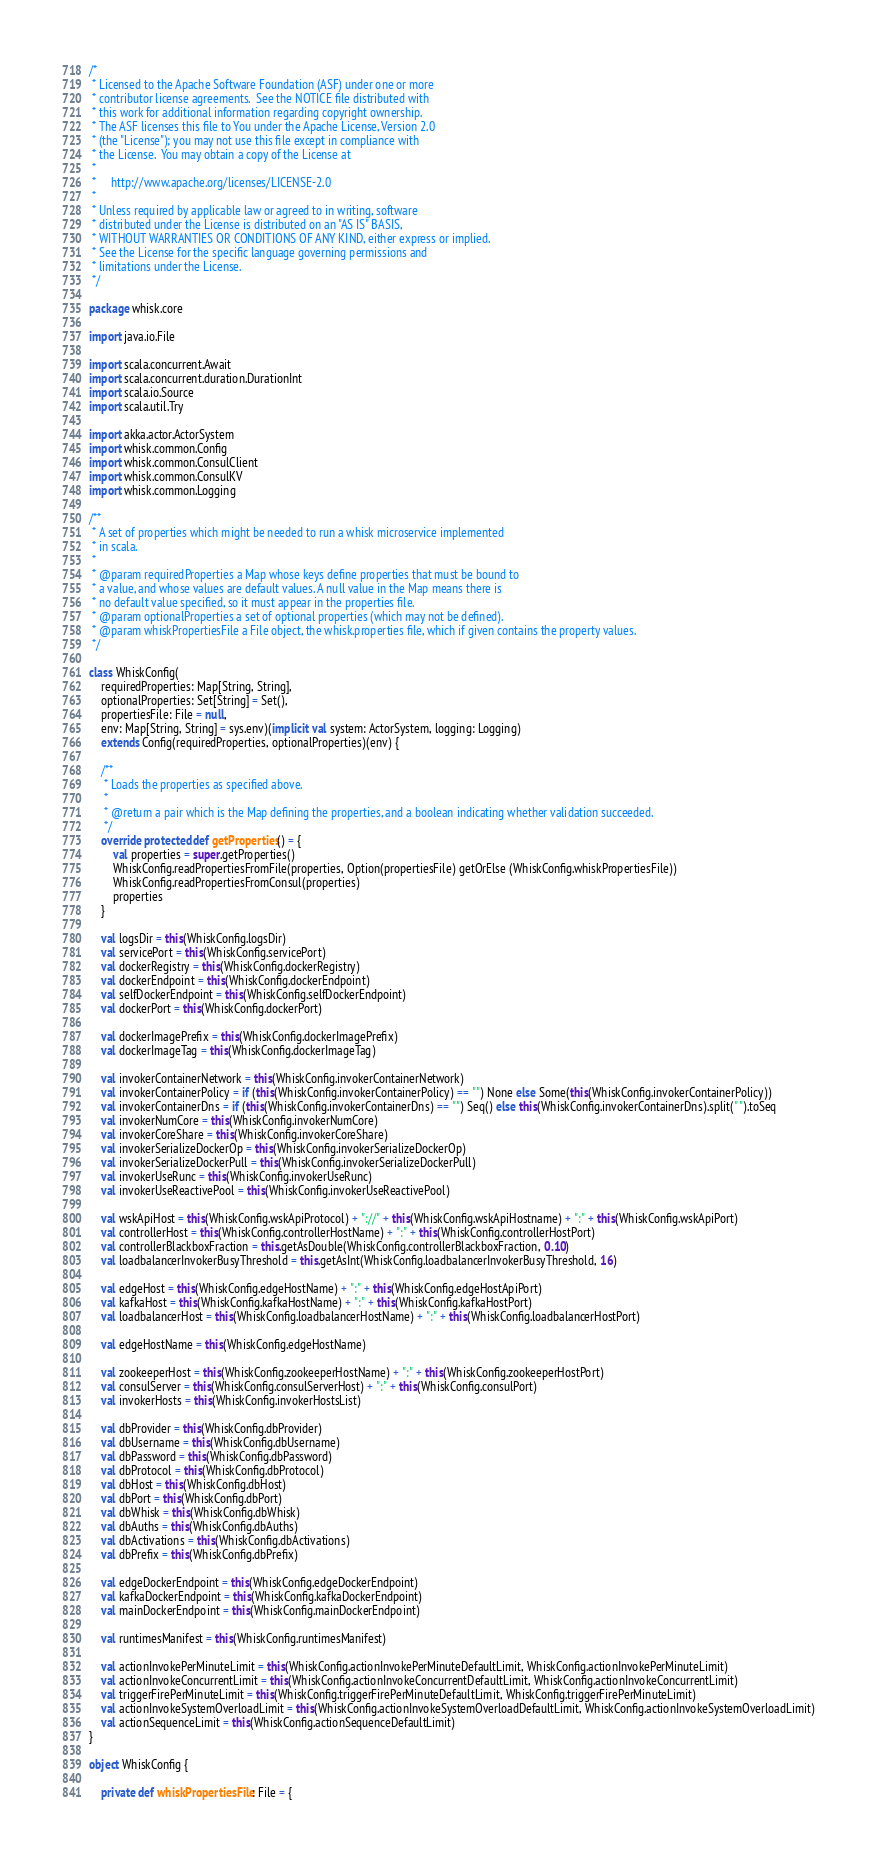<code> <loc_0><loc_0><loc_500><loc_500><_Scala_>/*
 * Licensed to the Apache Software Foundation (ASF) under one or more
 * contributor license agreements.  See the NOTICE file distributed with
 * this work for additional information regarding copyright ownership.
 * The ASF licenses this file to You under the Apache License, Version 2.0
 * (the "License"); you may not use this file except in compliance with
 * the License.  You may obtain a copy of the License at
 *
 *     http://www.apache.org/licenses/LICENSE-2.0
 *
 * Unless required by applicable law or agreed to in writing, software
 * distributed under the License is distributed on an "AS IS" BASIS,
 * WITHOUT WARRANTIES OR CONDITIONS OF ANY KIND, either express or implied.
 * See the License for the specific language governing permissions and
 * limitations under the License.
 */

package whisk.core

import java.io.File

import scala.concurrent.Await
import scala.concurrent.duration.DurationInt
import scala.io.Source
import scala.util.Try

import akka.actor.ActorSystem
import whisk.common.Config
import whisk.common.ConsulClient
import whisk.common.ConsulKV
import whisk.common.Logging

/**
 * A set of properties which might be needed to run a whisk microservice implemented
 * in scala.
 *
 * @param requiredProperties a Map whose keys define properties that must be bound to
 * a value, and whose values are default values. A null value in the Map means there is
 * no default value specified, so it must appear in the properties file.
 * @param optionalProperties a set of optional properties (which may not be defined).
 * @param whiskPropertiesFile a File object, the whisk.properties file, which if given contains the property values.
 */

class WhiskConfig(
    requiredProperties: Map[String, String],
    optionalProperties: Set[String] = Set(),
    propertiesFile: File = null,
    env: Map[String, String] = sys.env)(implicit val system: ActorSystem, logging: Logging)
    extends Config(requiredProperties, optionalProperties)(env) {

    /**
     * Loads the properties as specified above.
     *
     * @return a pair which is the Map defining the properties, and a boolean indicating whether validation succeeded.
     */
    override protected def getProperties() = {
        val properties = super.getProperties()
        WhiskConfig.readPropertiesFromFile(properties, Option(propertiesFile) getOrElse (WhiskConfig.whiskPropertiesFile))
        WhiskConfig.readPropertiesFromConsul(properties)
        properties
    }

    val logsDir = this(WhiskConfig.logsDir)
    val servicePort = this(WhiskConfig.servicePort)
    val dockerRegistry = this(WhiskConfig.dockerRegistry)
    val dockerEndpoint = this(WhiskConfig.dockerEndpoint)
    val selfDockerEndpoint = this(WhiskConfig.selfDockerEndpoint)
    val dockerPort = this(WhiskConfig.dockerPort)

    val dockerImagePrefix = this(WhiskConfig.dockerImagePrefix)
    val dockerImageTag = this(WhiskConfig.dockerImageTag)

    val invokerContainerNetwork = this(WhiskConfig.invokerContainerNetwork)
    val invokerContainerPolicy = if (this(WhiskConfig.invokerContainerPolicy) == "") None else Some(this(WhiskConfig.invokerContainerPolicy))
    val invokerContainerDns = if (this(WhiskConfig.invokerContainerDns) == "") Seq() else this(WhiskConfig.invokerContainerDns).split(" ").toSeq
    val invokerNumCore = this(WhiskConfig.invokerNumCore)
    val invokerCoreShare = this(WhiskConfig.invokerCoreShare)
    val invokerSerializeDockerOp = this(WhiskConfig.invokerSerializeDockerOp)
    val invokerSerializeDockerPull = this(WhiskConfig.invokerSerializeDockerPull)
    val invokerUseRunc = this(WhiskConfig.invokerUseRunc)
    val invokerUseReactivePool = this(WhiskConfig.invokerUseReactivePool)

    val wskApiHost = this(WhiskConfig.wskApiProtocol) + "://" + this(WhiskConfig.wskApiHostname) + ":" + this(WhiskConfig.wskApiPort)
    val controllerHost = this(WhiskConfig.controllerHostName) + ":" + this(WhiskConfig.controllerHostPort)
    val controllerBlackboxFraction = this.getAsDouble(WhiskConfig.controllerBlackboxFraction, 0.10)
    val loadbalancerInvokerBusyThreshold = this.getAsInt(WhiskConfig.loadbalancerInvokerBusyThreshold, 16)

    val edgeHost = this(WhiskConfig.edgeHostName) + ":" + this(WhiskConfig.edgeHostApiPort)
    val kafkaHost = this(WhiskConfig.kafkaHostName) + ":" + this(WhiskConfig.kafkaHostPort)
    val loadbalancerHost = this(WhiskConfig.loadbalancerHostName) + ":" + this(WhiskConfig.loadbalancerHostPort)

    val edgeHostName = this(WhiskConfig.edgeHostName)

    val zookeeperHost = this(WhiskConfig.zookeeperHostName) + ":" + this(WhiskConfig.zookeeperHostPort)
    val consulServer = this(WhiskConfig.consulServerHost) + ":" + this(WhiskConfig.consulPort)
    val invokerHosts = this(WhiskConfig.invokerHostsList)

    val dbProvider = this(WhiskConfig.dbProvider)
    val dbUsername = this(WhiskConfig.dbUsername)
    val dbPassword = this(WhiskConfig.dbPassword)
    val dbProtocol = this(WhiskConfig.dbProtocol)
    val dbHost = this(WhiskConfig.dbHost)
    val dbPort = this(WhiskConfig.dbPort)
    val dbWhisk = this(WhiskConfig.dbWhisk)
    val dbAuths = this(WhiskConfig.dbAuths)
    val dbActivations = this(WhiskConfig.dbActivations)
    val dbPrefix = this(WhiskConfig.dbPrefix)

    val edgeDockerEndpoint = this(WhiskConfig.edgeDockerEndpoint)
    val kafkaDockerEndpoint = this(WhiskConfig.kafkaDockerEndpoint)
    val mainDockerEndpoint = this(WhiskConfig.mainDockerEndpoint)

    val runtimesManifest = this(WhiskConfig.runtimesManifest)

    val actionInvokePerMinuteLimit = this(WhiskConfig.actionInvokePerMinuteDefaultLimit, WhiskConfig.actionInvokePerMinuteLimit)
    val actionInvokeConcurrentLimit = this(WhiskConfig.actionInvokeConcurrentDefaultLimit, WhiskConfig.actionInvokeConcurrentLimit)
    val triggerFirePerMinuteLimit = this(WhiskConfig.triggerFirePerMinuteDefaultLimit, WhiskConfig.triggerFirePerMinuteLimit)
    val actionInvokeSystemOverloadLimit = this(WhiskConfig.actionInvokeSystemOverloadDefaultLimit, WhiskConfig.actionInvokeSystemOverloadLimit)
    val actionSequenceLimit = this(WhiskConfig.actionSequenceDefaultLimit)
}

object WhiskConfig {

    private def whiskPropertiesFile: File = {</code> 